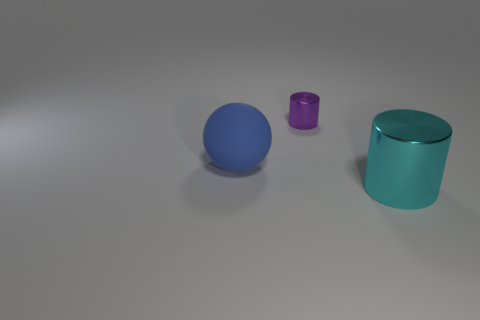Subtract all cyan cylinders. How many cylinders are left? 1 Subtract all spheres. How many objects are left? 2 Add 3 big cyan metal things. How many objects exist? 6 Subtract 1 spheres. How many spheres are left? 0 Add 2 small blue cylinders. How many small blue cylinders exist? 2 Subtract 0 cyan cubes. How many objects are left? 3 Subtract all purple cylinders. Subtract all red spheres. How many cylinders are left? 1 Subtract all yellow balls. How many purple cylinders are left? 1 Subtract all tiny brown metal cylinders. Subtract all small purple shiny cylinders. How many objects are left? 2 Add 2 large cyan objects. How many large cyan objects are left? 3 